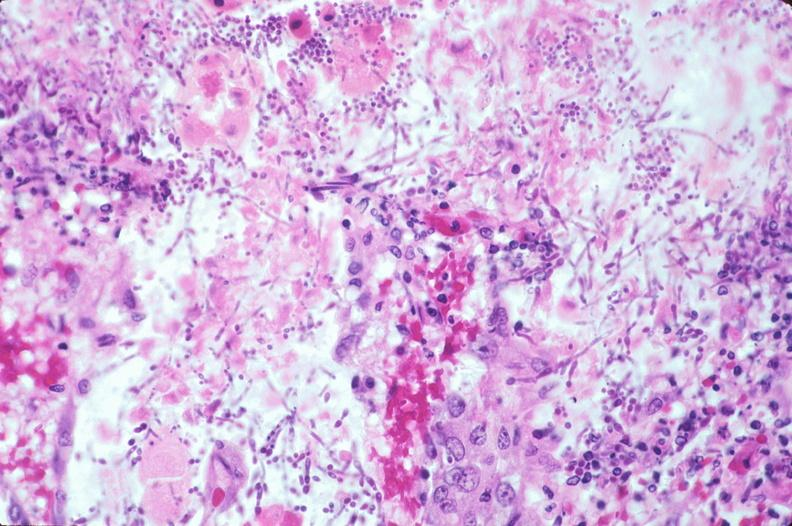does siamese twins show duodenum, necrotizing enteritis with pseudomembrane, candida?
Answer the question using a single word or phrase. No 